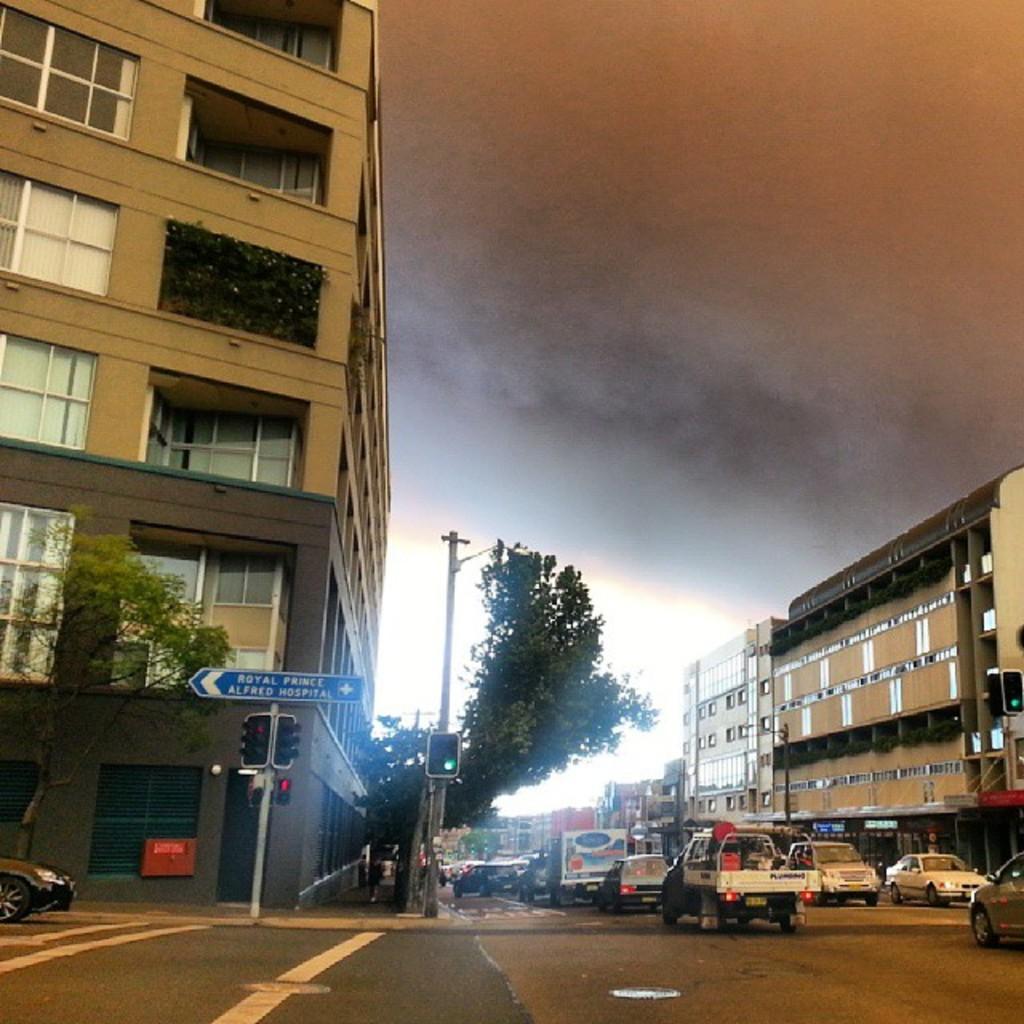Please provide a concise description of this image. In this image, there are a few vehicles and buildings. We can see the ground and some trees. We can also see some poles with lights and wires. We can see a board with some text. We can see the ground and the sky. There are a few people. 